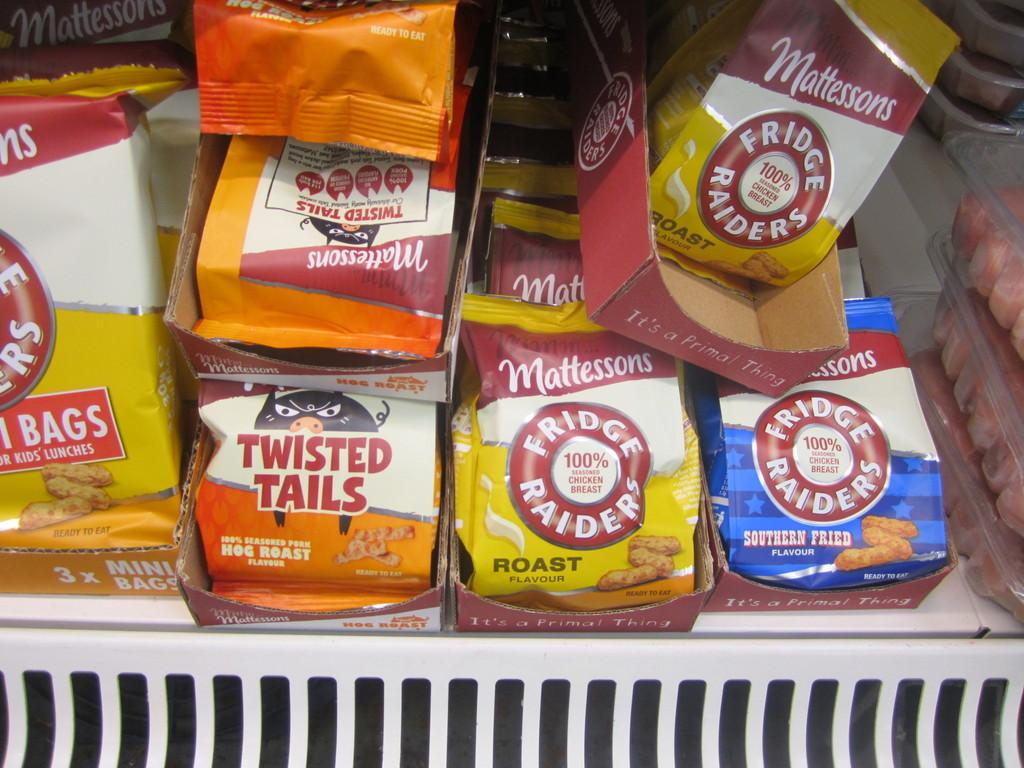What type of waste is present in the image? There are snack wrappers in the image. Where are the snack wrappers located in the image? The snack wrappers are in the center of the image. How are the snack wrappers stored in the image? The snack wrappers are inside a rack. What other type of food packaging can be seen in the image? There are candy boxes in the image. On which side of the image are the candy boxes located? The candy boxes are on the right side of the image. What type of insurance policy is being discussed in the image? There is no discussion of insurance policies in the image; it features snack wrappers and candy boxes. How many men are visible in the image? There are no men present in the image. 